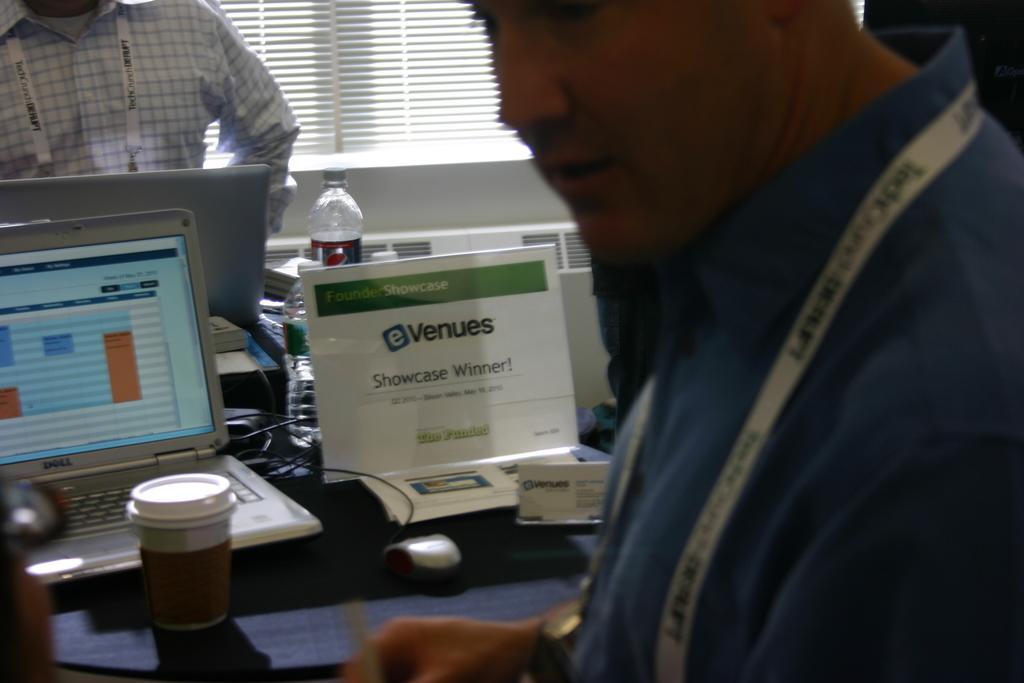Describe this image in one or two sentences. In this image, we can see persons wearing clothes. There is a table in the middle of the image contains laptop, mouse, bottles, board and cup. There is a window at the top of the image. 